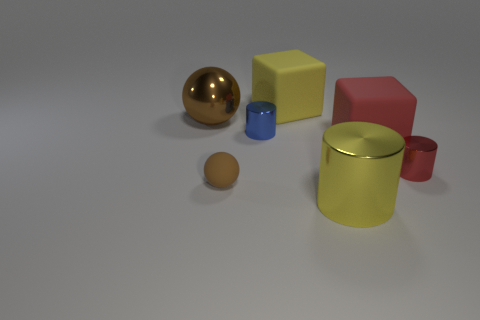Subtract all yellow cylinders. Subtract all gray blocks. How many cylinders are left? 2 Add 3 large cyan cubes. How many objects exist? 10 Subtract all cylinders. How many objects are left? 4 Subtract 0 blue spheres. How many objects are left? 7 Subtract all big red blocks. Subtract all red metal things. How many objects are left? 5 Add 2 tiny cylinders. How many tiny cylinders are left? 4 Add 3 purple rubber objects. How many purple rubber objects exist? 3 